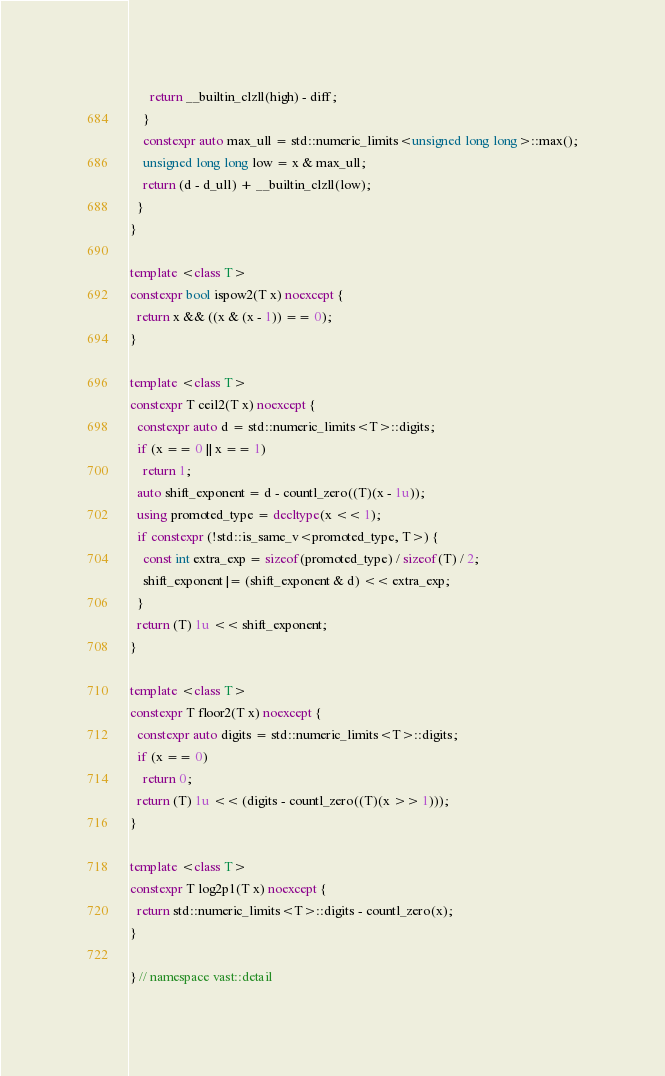Convert code to text. <code><loc_0><loc_0><loc_500><loc_500><_C++_>      return __builtin_clzll(high) - diff;
    }
    constexpr auto max_ull = std::numeric_limits<unsigned long long>::max();
    unsigned long long low = x & max_ull;
    return (d - d_ull) + __builtin_clzll(low);
  }
}

template <class T>
constexpr bool ispow2(T x) noexcept {
  return x && ((x & (x - 1)) == 0);
}

template <class T>
constexpr T ceil2(T x) noexcept {
  constexpr auto d = std::numeric_limits<T>::digits;
  if (x == 0 || x == 1)
    return 1;
  auto shift_exponent = d - countl_zero((T)(x - 1u));
  using promoted_type = decltype(x << 1);
  if constexpr (!std::is_same_v<promoted_type, T>) {
    const int extra_exp = sizeof(promoted_type) / sizeof(T) / 2;
    shift_exponent |= (shift_exponent & d) << extra_exp;
  }
  return (T) 1u << shift_exponent;
}

template <class T>
constexpr T floor2(T x) noexcept {
  constexpr auto digits = std::numeric_limits<T>::digits;
  if (x == 0)
    return 0;
  return (T) 1u << (digits - countl_zero((T)(x >> 1)));
}

template <class T>
constexpr T log2p1(T x) noexcept {
  return std::numeric_limits<T>::digits - countl_zero(x);
}

} // namespace vast::detail
</code> 